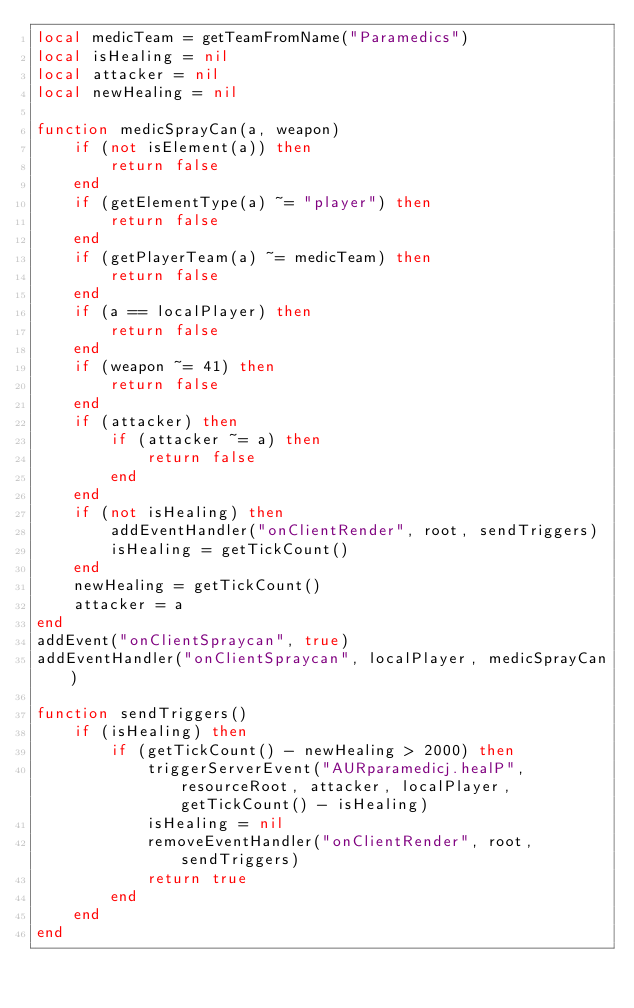Convert code to text. <code><loc_0><loc_0><loc_500><loc_500><_Lua_>local medicTeam = getTeamFromName("Paramedics")
local isHealing = nil
local attacker = nil
local newHealing = nil

function medicSprayCan(a, weapon)
	if (not isElement(a)) then
		return false 
	end
	if (getElementType(a) ~= "player") then
		return false 
	end
	if (getPlayerTeam(a) ~= medicTeam) then
		return false 
	end
	if (a == localPlayer) then
		return false 
	end
	if (weapon ~= 41) then
		return false
	end
	if (attacker) then
		if (attacker ~= a) then
			return false 
		end
	end
	if (not isHealing) then
		addEventHandler("onClientRender", root, sendTriggers)
		isHealing = getTickCount()
	end
	newHealing = getTickCount()
	attacker = a
end
addEvent("onClientSpraycan", true)
addEventHandler("onClientSpraycan", localPlayer, medicSprayCan)

function sendTriggers()
	if (isHealing) then
		if (getTickCount() - newHealing > 2000) then
			triggerServerEvent("AURparamedicj.healP", resourceRoot, attacker, localPlayer, getTickCount() - isHealing)
			isHealing = nil 
			removeEventHandler("onClientRender", root, sendTriggers)
			return true 
		end
	end
end
</code> 